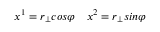<formula> <loc_0><loc_0><loc_500><loc_500>x ^ { 1 } = r _ { \bot } \cos \varphi \quad x ^ { 2 } = r _ { \bot } \sin \varphi</formula> 